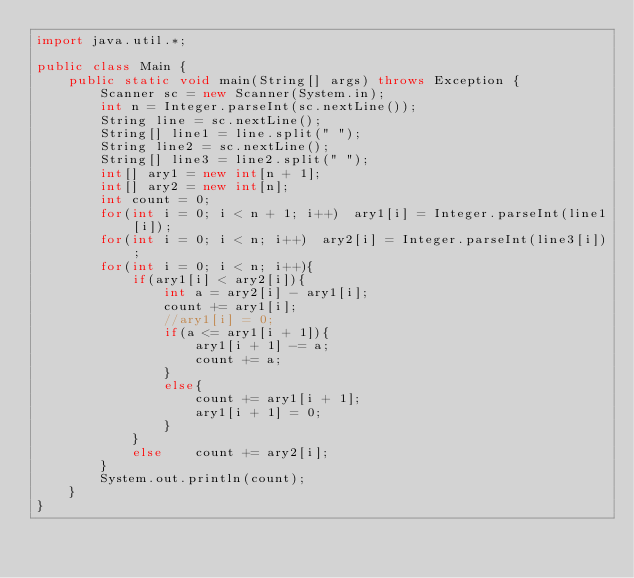<code> <loc_0><loc_0><loc_500><loc_500><_Java_>import java.util.*;

public class Main {
    public static void main(String[] args) throws Exception {
        Scanner sc = new Scanner(System.in);
        int n = Integer.parseInt(sc.nextLine());
        String line = sc.nextLine();
        String[] line1 = line.split(" ");
        String line2 = sc.nextLine();
        String[] line3 = line2.split(" ");
        int[] ary1 = new int[n + 1];
        int[] ary2 = new int[n];
        int count = 0;
        for(int i = 0; i < n + 1; i++)  ary1[i] = Integer.parseInt(line1[i]);
        for(int i = 0; i < n; i++)  ary2[i] = Integer.parseInt(line3[i]);
        for(int i = 0; i < n; i++){
            if(ary1[i] < ary2[i]){
                int a = ary2[i] - ary1[i];
                count += ary1[i];
                //ary1[i] = 0;
                if(a <= ary1[i + 1]){
                    ary1[i + 1] -= a;
                    count += a;
                }
                else{
                    count += ary1[i + 1];
                    ary1[i + 1] = 0;
                }
            }
            else    count += ary2[i];
        }
        System.out.println(count);
    }
}</code> 